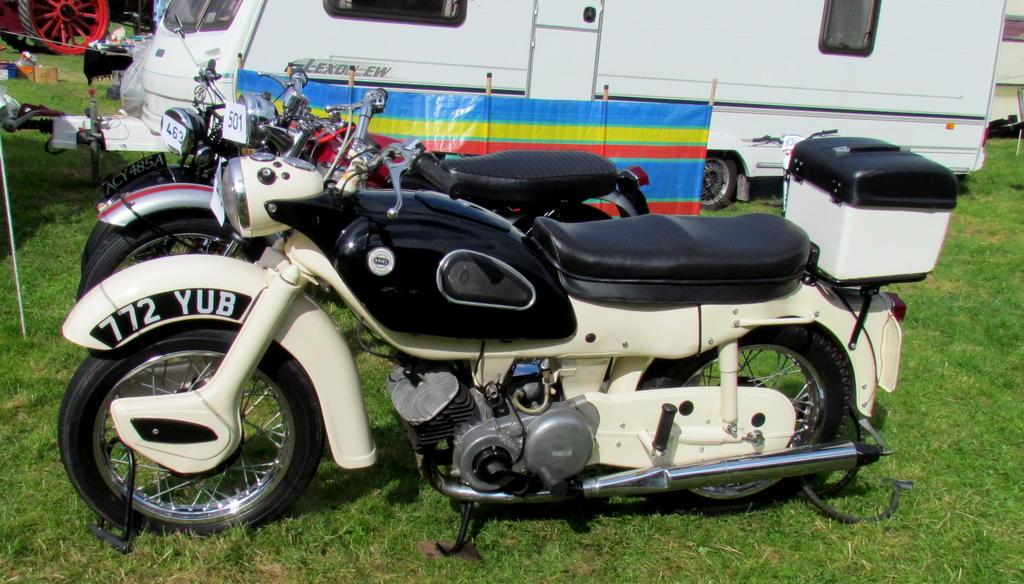What types of vehicles can be seen in the image? There are vehicles present on the ground in the image. What type of natural environment is visible in the image? There is grass visible in the image. What type of linen is being used to cover the church in the image? There is no church or linen present in the image. How many combs are visible in the image? There are no combs visible in the image. 